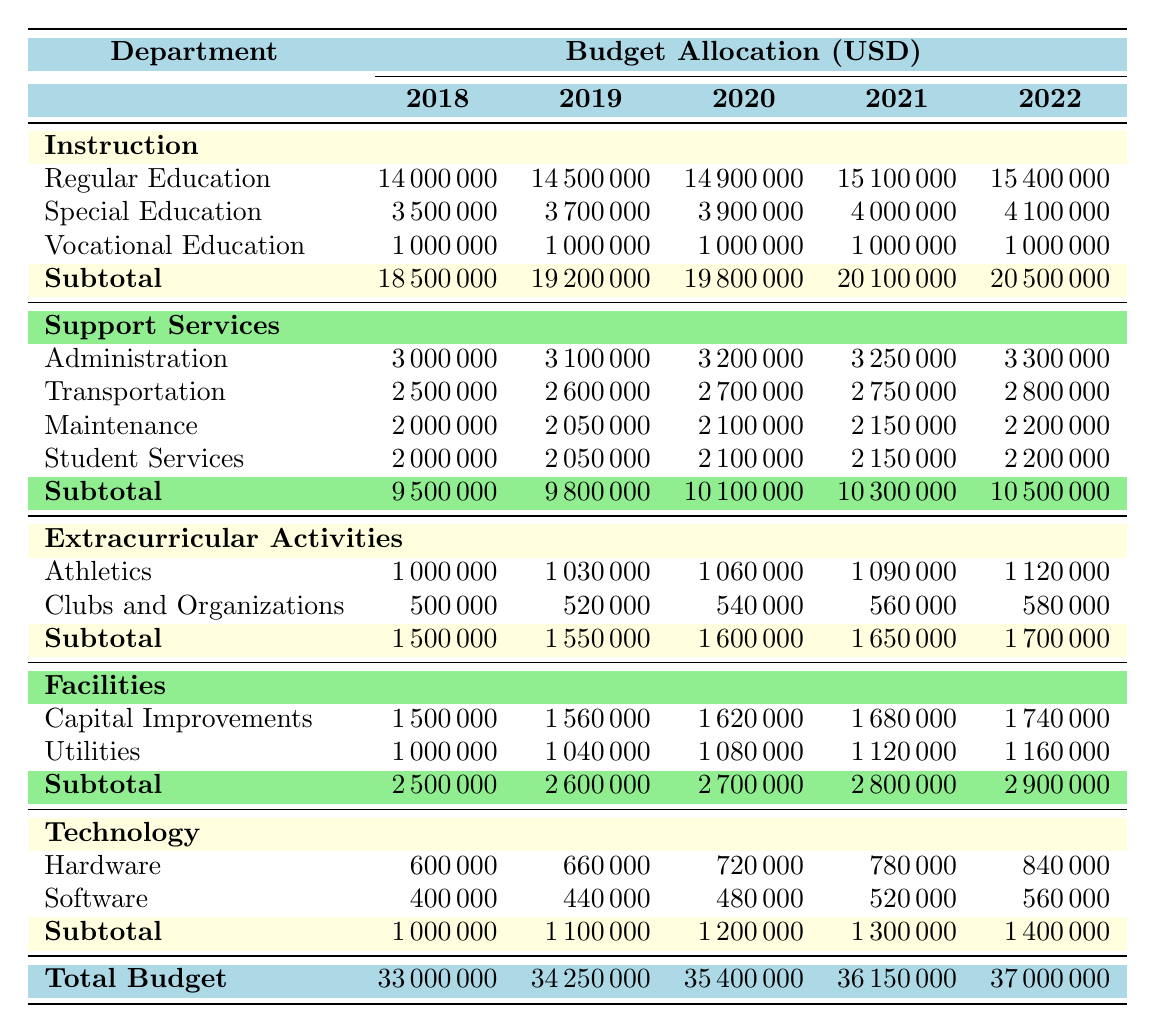What was the budget allocation for Instruction in 2022? The table shows that the budget allocation for Instruction in 2022 is listed under the "Instruction" section. The amount is 20,500,000 USD.
Answer: 20,500,000 USD What was the total budget for the Alliance City School District in 2020? The total budget is located in the "Total Budget" row for the year 2020, which states 35,400,000 USD.
Answer: 35,400,000 USD Which department had the highest subtotal in 2021? By examining the subtotals for all departments in 2021, the "Instruction" department has the highest subtotal at 20,100,000 USD.
Answer: Instruction How much did Support Services increase from 2018 to 2022? The 2018 subtotal for Support Services is 9,500,000 USD, and in 2022 it is 10,500,000 USD. The increase is calculated as 10,500,000 - 9,500,000 = 1,000,000 USD.
Answer: 1,000,000 USD What is the average budget allocation for Extracurricular Activities from 2018 to 2022? To find the average, sum the amounts for the Extracurricular Activities from 2018 to 2022: (1,500,000 + 1,550,000 + 1,600,000 + 1,650,000 + 1,700,000) = 7,000,000 USD. Now divide by 5 to get the average: 7,000,000 / 5 = 1,400,000 USD.
Answer: 1,400,000 USD Does Maintenance have a higher budget than Administration in 2021? In 2021, the budget for Maintenance is 2,150,000 USD and for Administration is 3,250,000 USD. Since 2,150,000 is less than 3,250,000, the statement is false.
Answer: No What is the total budget allocation for Technology over the five years? The Technology subcategory totals over the five years are: 1,000,000 + 1,100,000 + 1,200,000 + 1,300,000 + 1,400,000 = 6,000,000 USD.
Answer: 6,000,000 USD What was the budget allocation for Special Education in 2019? The table indicates that the budget for Special Education in 2019 is 3,700,000 USD, listed under the Instruction department.
Answer: 3,700,000 USD In which year did the total budget reach 36,150,000 USD? By checking the "Total Budget" row, 36,150,000 USD is found in the column for the year 2021.
Answer: 2021 How much more was spent on Capital Improvements than Utilities in 2022? In 2022, Capital Improvements is 1,740,000 USD and Utilities is 1,160,000 USD. The difference is 1,740,000 - 1,160,000 = 580,000 USD.
Answer: 580,000 USD 